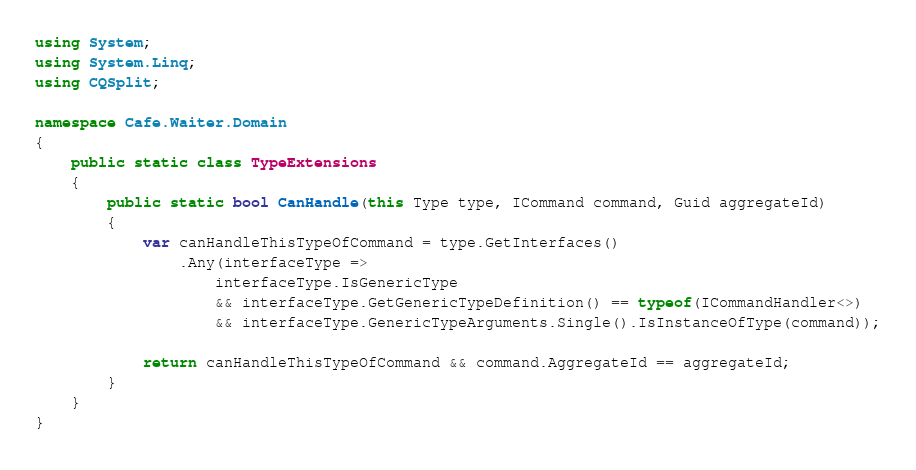<code> <loc_0><loc_0><loc_500><loc_500><_C#_>using System;
using System.Linq;
using CQSplit;

namespace Cafe.Waiter.Domain
{
    public static class TypeExtensions
    {
        public static bool CanHandle(this Type type, ICommand command, Guid aggregateId)
        {
            var canHandleThisTypeOfCommand = type.GetInterfaces()
                .Any(interfaceType =>
                    interfaceType.IsGenericType
                    && interfaceType.GetGenericTypeDefinition() == typeof(ICommandHandler<>)
                    && interfaceType.GenericTypeArguments.Single().IsInstanceOfType(command));

            return canHandleThisTypeOfCommand && command.AggregateId == aggregateId;
        }
    }
}</code> 